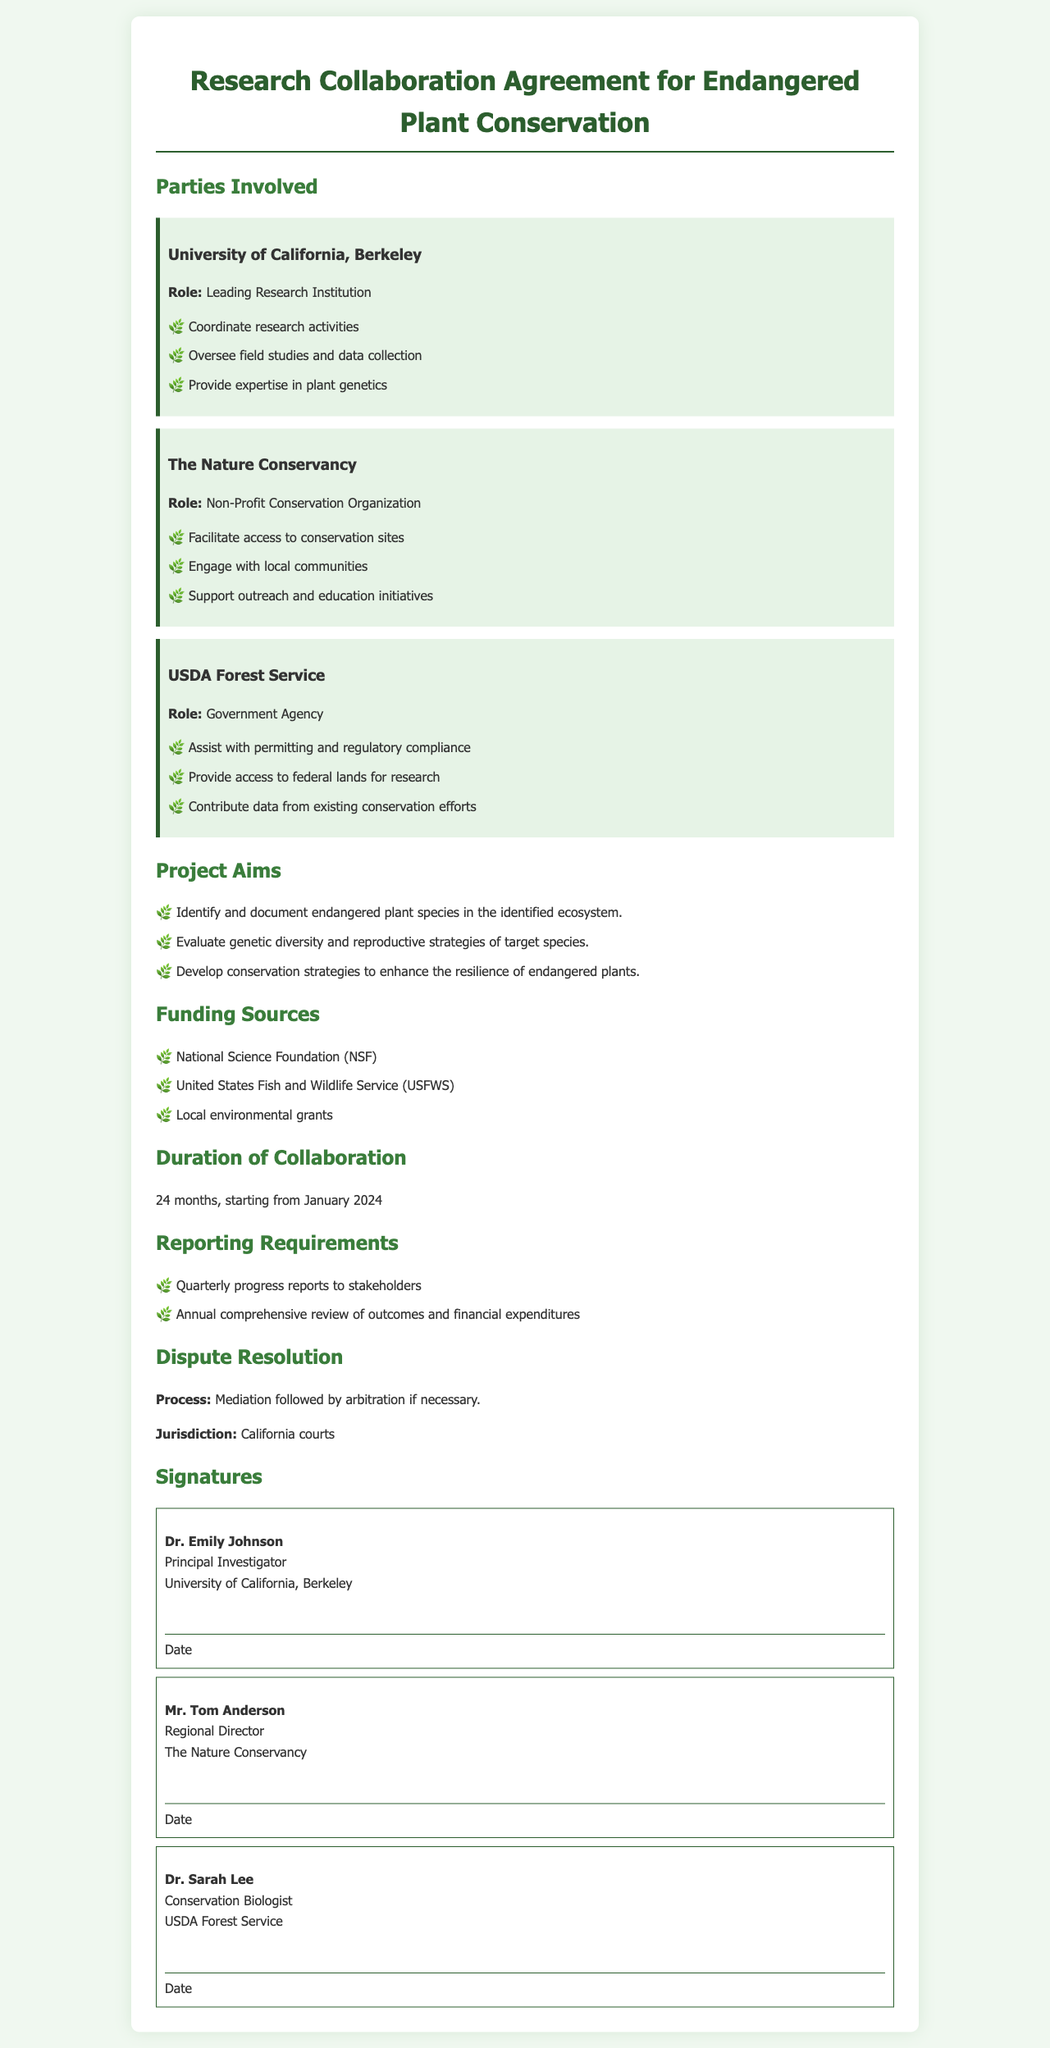What is the leading research institution in the agreement? The document identifies the University of California, Berkeley as the leading research institution involved in the collaboration.
Answer: University of California, Berkeley How long is the duration of collaboration? The document states that the duration of collaboration is for 24 months, starting from January 2024.
Answer: 24 months Who is the principal investigator? The document clearly names Dr. Emily Johnson as the principal investigator.
Answer: Dr. Emily Johnson What is the role of The Nature Conservancy? The document specifies that The Nature Conservancy serves as a non-profit conservation organization with defined responsibilities.
Answer: Non-Profit Conservation Organization What are the reporting requirements mentioned in the document? The document outlines that quarterly progress reports and an annual comprehensive review are required for stakeholders.
Answer: Quarterly progress reports and annual comprehensive review What strategies are included in the project aims? The document mentions developing conservation strategies to enhance the resilience of endangered plants as one of its aims.
Answer: Develop conservation strategies What is the process for dispute resolution? The document outlines that the dispute resolution process begins with mediation followed by arbitration, if necessary.
Answer: Mediation followed by arbitration Which agencies are identified as funding sources? The document lists funding sources such as the National Science Foundation, United States Fish and Wildlife Service, and local environmental grants.
Answer: National Science Foundation, US Fish and Wildlife Service, local environmental grants What jurisdiction is specified for legal matters? The document states that California courts have jurisdiction over legal matters related to the agreement.
Answer: California courts 